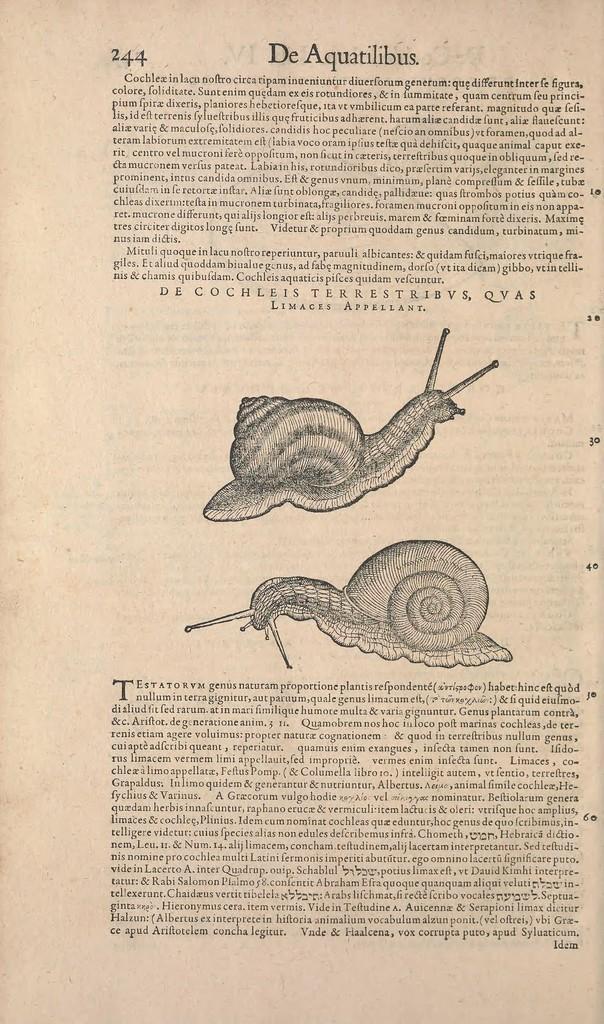How would you summarize this image in a sentence or two? In the picture we can see some text and images which are taken from a book. 